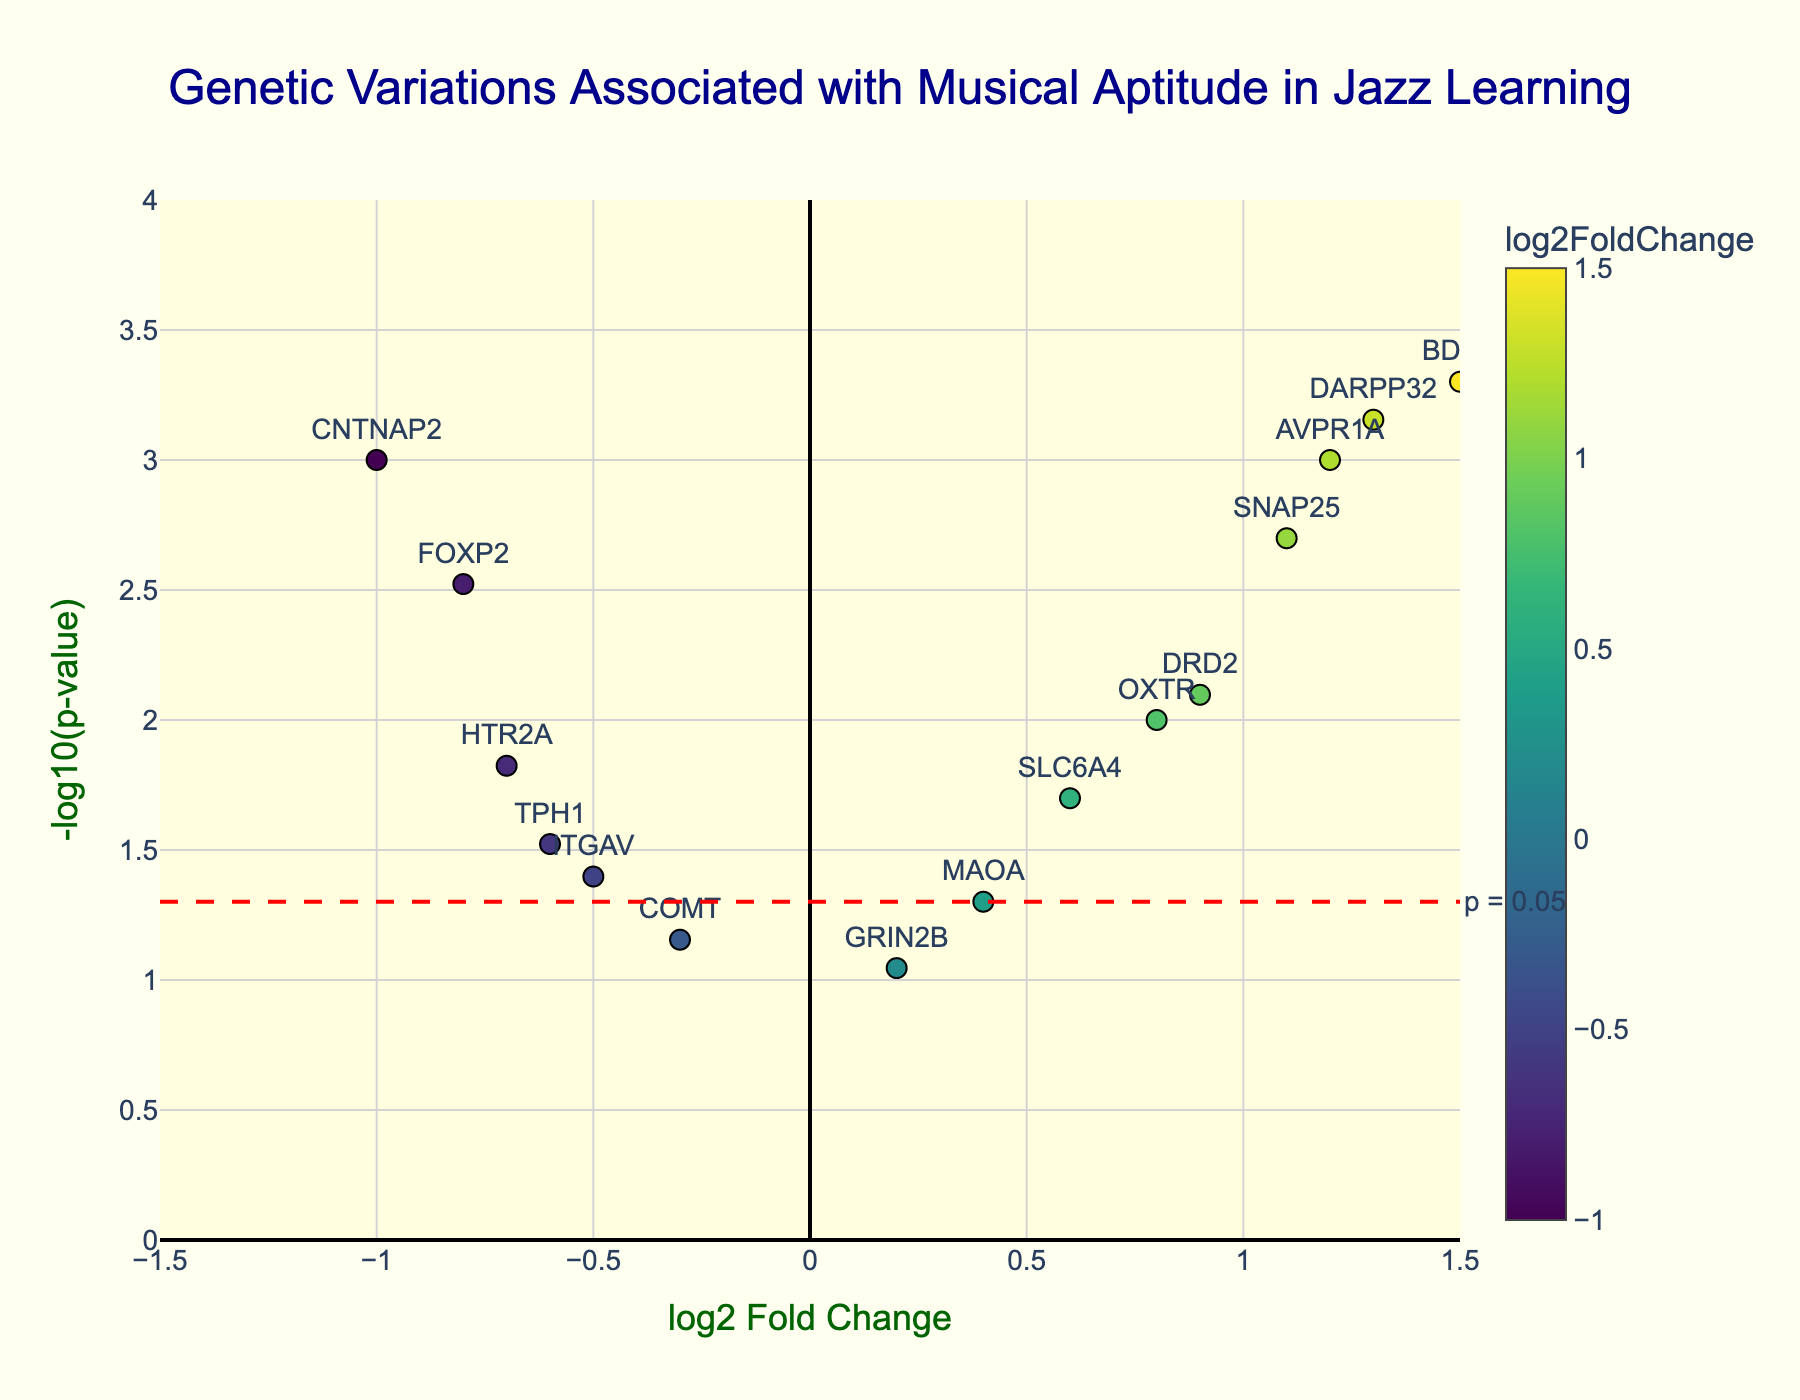What is the title of the figure? The title is written at the top center of the figure in large dark blue font. It reads "Genetic Variations Associated with Musical Aptitude in Jazz Learning".
Answer: Genetic Variations Associated with Musical Aptitude in Jazz Learning How many genes are represented in the plot? Each data point represents a gene, and there are 15 unique data points plotted.
Answer: 15 What are the axes labels of the plot? The x-axis title is "log2 Fold Change" and the y-axis title is "-log10(p-value)". Both titles are displayed in dark green font.
Answer: log2 Fold Change and -log10(p-value) Which gene has the highest log2 fold change? The x-axis represents log2 Fold Change. The gene furthest to the right on this axis is BDNF, indicating it has the highest value.
Answer: BDNF Which gene is the most statistically significant? Significance is determined by the p-value, represented by the y-axis. The higher the -log10(p-value), the more significant. The highest point on the y-axis is BDNF.
Answer: BDNF What is the p-value threshold line, and what does it represent? The plot includes a red horizontal dashed line labeled "p = 0.05". This line represents the significance threshold for p-value; points above this line have p-values less than 0.05 and are considered statistically significant.
Answer: p = 0.05 How many genes have p-values less than 0.05? Data points above the red dashed line represent genes with p-values less than 0.05. There are 9 such points.
Answer: 9 Compare the log2 fold change between FOXP2 and BDNF. Which is larger and by how much? FOXP2 has a log2 fold change of -0.8, while BDNF has 1.5. The difference is 1.5 - (-0.8) = 2.3, so BDNF is larger by 2.3.
Answer: BDNF by 2.3 For the gene OXTR, what is its log2 fold change and p-value? The gene OXTR has a log2 fold change of 0.8 and is located around y=2 in the plot, corresponding to its -log10(p-value) value. This equates to a p-value of around 0.01 (since -log10(0.01)=2).
Answer: 0.8 and 0.01 What color scale is used to indicate the log2 fold change of each gene? The color of the data points varies along a scale from light to dark, labeled as "Viridis" in the color bar on the right side of the plot.
Answer: Viridis 